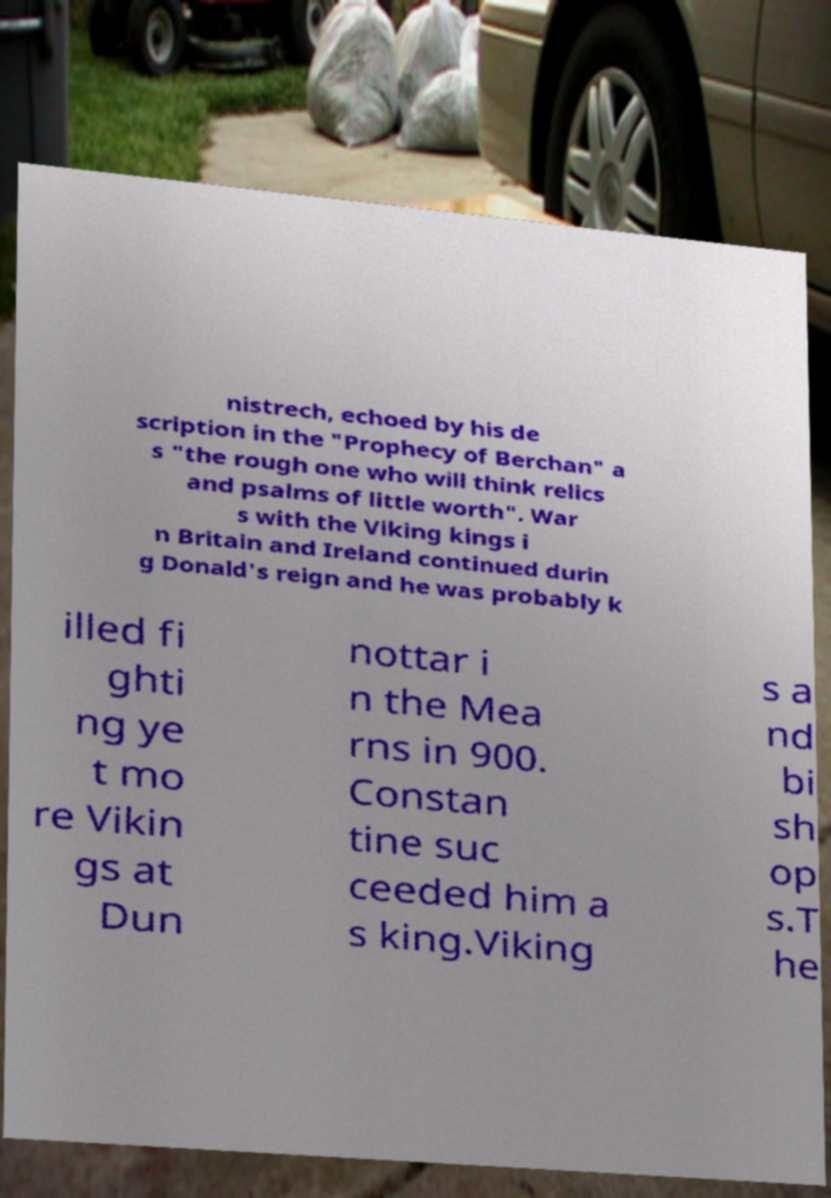There's text embedded in this image that I need extracted. Can you transcribe it verbatim? nistrech, echoed by his de scription in the "Prophecy of Berchan" a s "the rough one who will think relics and psalms of little worth". War s with the Viking kings i n Britain and Ireland continued durin g Donald's reign and he was probably k illed fi ghti ng ye t mo re Vikin gs at Dun nottar i n the Mea rns in 900. Constan tine suc ceeded him a s king.Viking s a nd bi sh op s.T he 